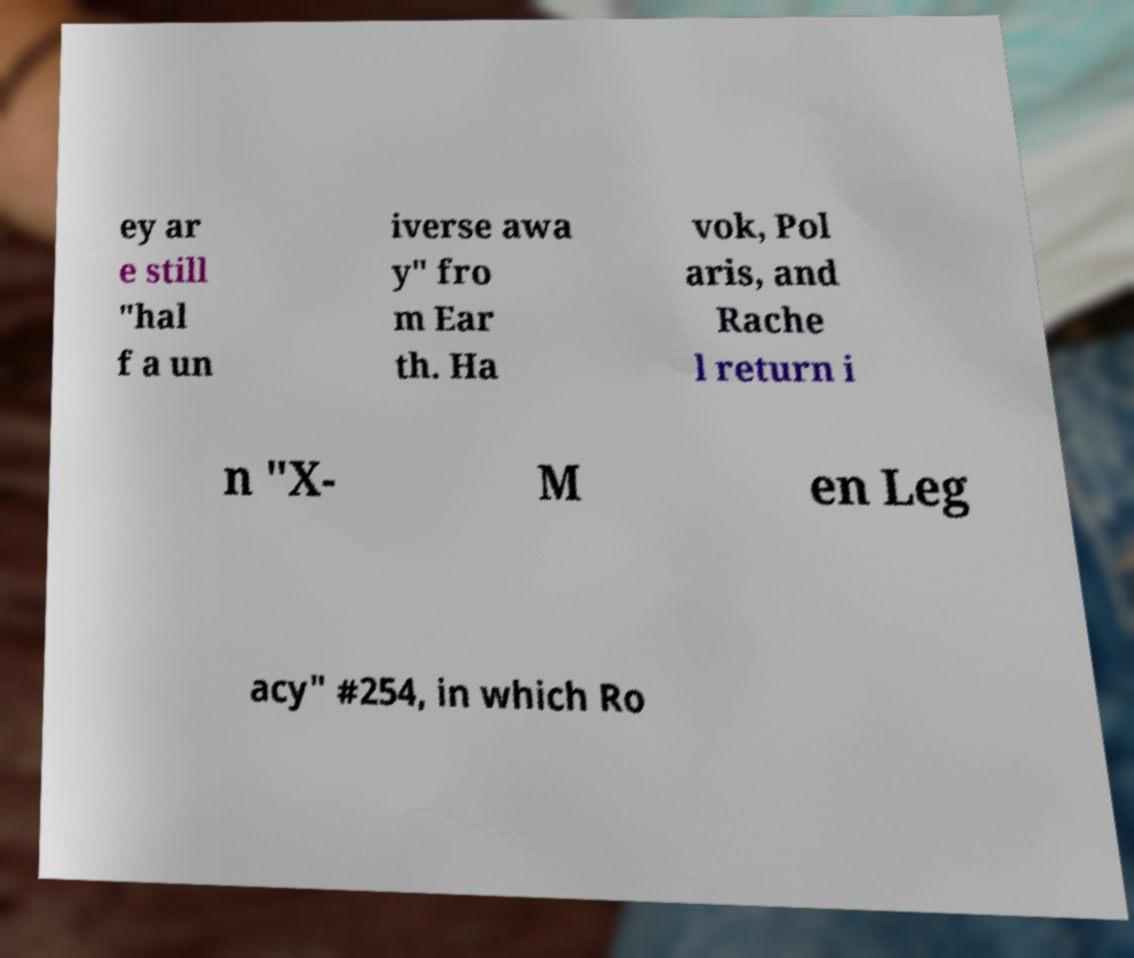What messages or text are displayed in this image? I need them in a readable, typed format. ey ar e still "hal f a un iverse awa y" fro m Ear th. Ha vok, Pol aris, and Rache l return i n "X- M en Leg acy" #254, in which Ro 